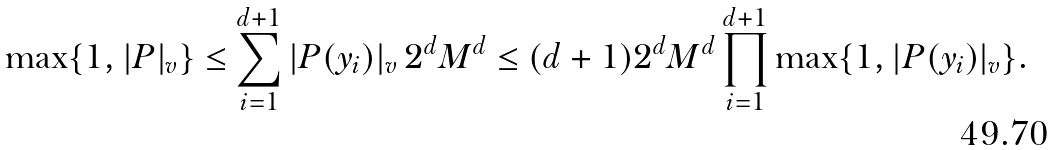Convert formula to latex. <formula><loc_0><loc_0><loc_500><loc_500>\max \{ 1 , | P | _ { v } \} \leq \sum _ { i = 1 } ^ { d + 1 } | P ( y _ { i } ) | _ { v } \, 2 ^ { d } M ^ { d } \leq ( d + 1 ) 2 ^ { d } M ^ { d } \prod _ { i = 1 } ^ { d + 1 } \max \{ 1 , | P ( y _ { i } ) | _ { v } \} .</formula> 